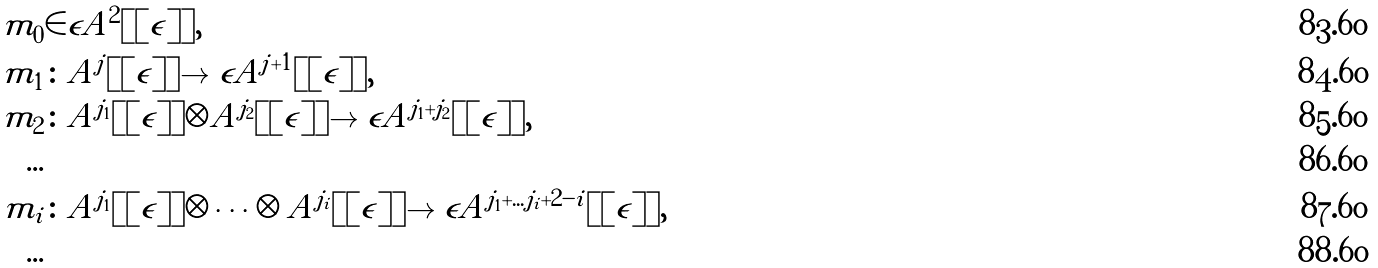Convert formula to latex. <formula><loc_0><loc_0><loc_500><loc_500>m _ { 0 } & \in \epsilon A ^ { 2 } [ [ \epsilon ] ] , \\ m _ { 1 } & \colon A ^ { j } [ [ \epsilon ] ] \to \epsilon A ^ { j + 1 } [ [ \epsilon ] ] , \\ m _ { 2 } & \colon A ^ { j _ { 1 } } [ [ \epsilon ] ] \otimes A ^ { j _ { 2 } } [ [ \epsilon ] ] \to \epsilon A ^ { j _ { 1 } + j _ { 2 } } [ [ \epsilon ] ] , \\ \dots \\ m _ { i } & \colon A ^ { j _ { 1 } } [ [ \epsilon ] ] \otimes \dots \otimes A ^ { j _ { i } } [ [ \epsilon ] ] \to \epsilon A ^ { j _ { 1 } + \dots j _ { i } + 2 - i } [ [ \epsilon ] ] , \\ \dots</formula> 